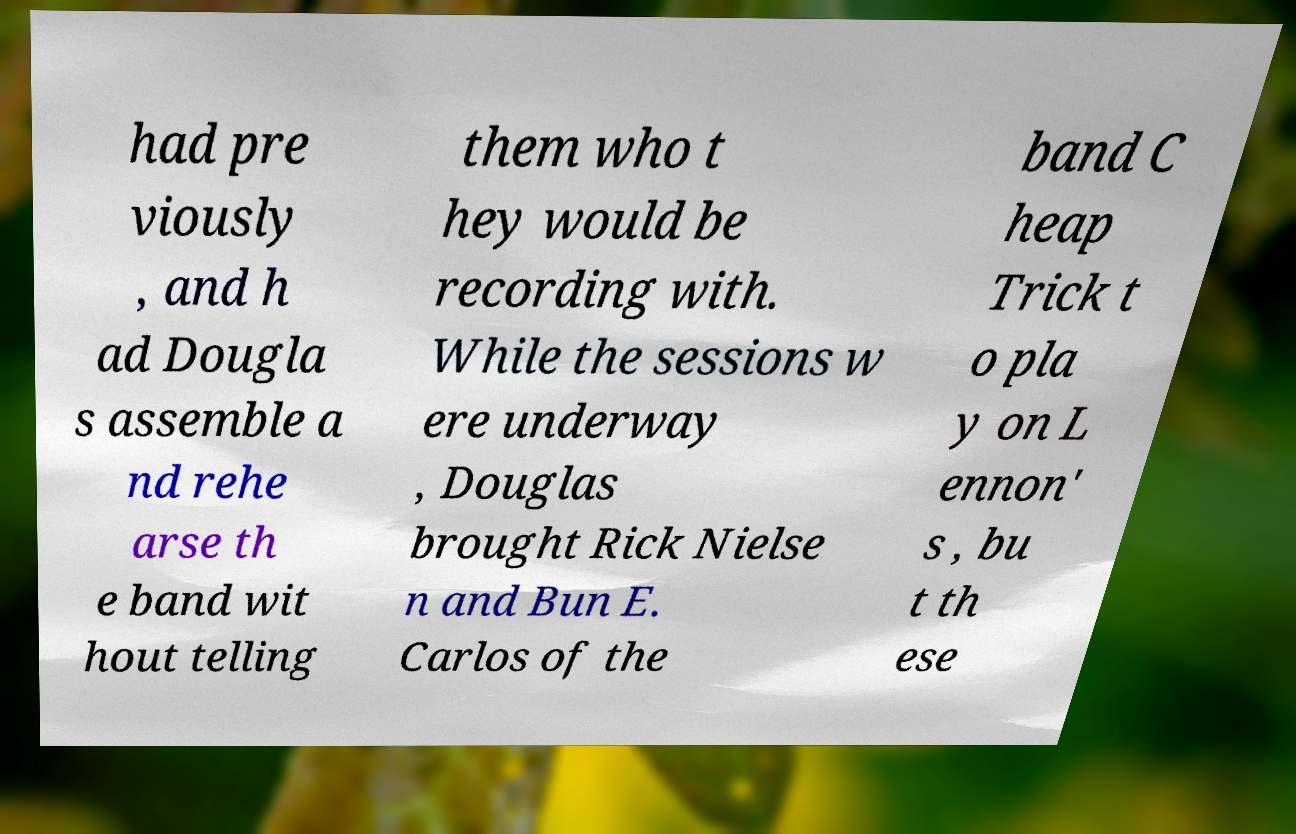Can you accurately transcribe the text from the provided image for me? had pre viously , and h ad Dougla s assemble a nd rehe arse th e band wit hout telling them who t hey would be recording with. While the sessions w ere underway , Douglas brought Rick Nielse n and Bun E. Carlos of the band C heap Trick t o pla y on L ennon' s , bu t th ese 